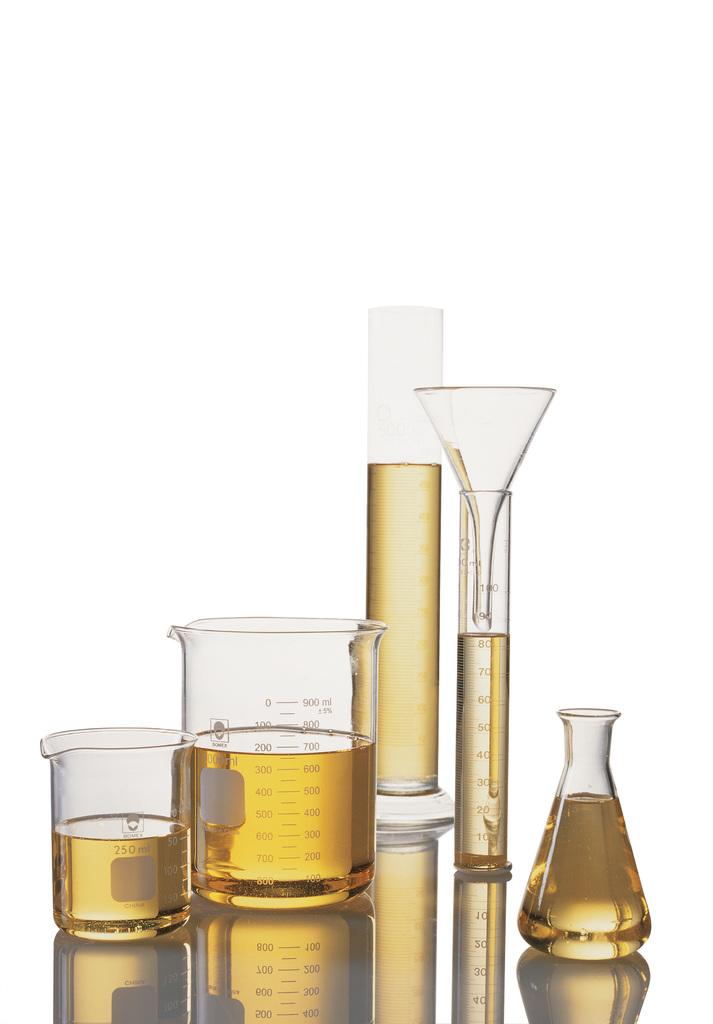How much can the leftmost container measure?
Give a very brief answer. 250 ml. 